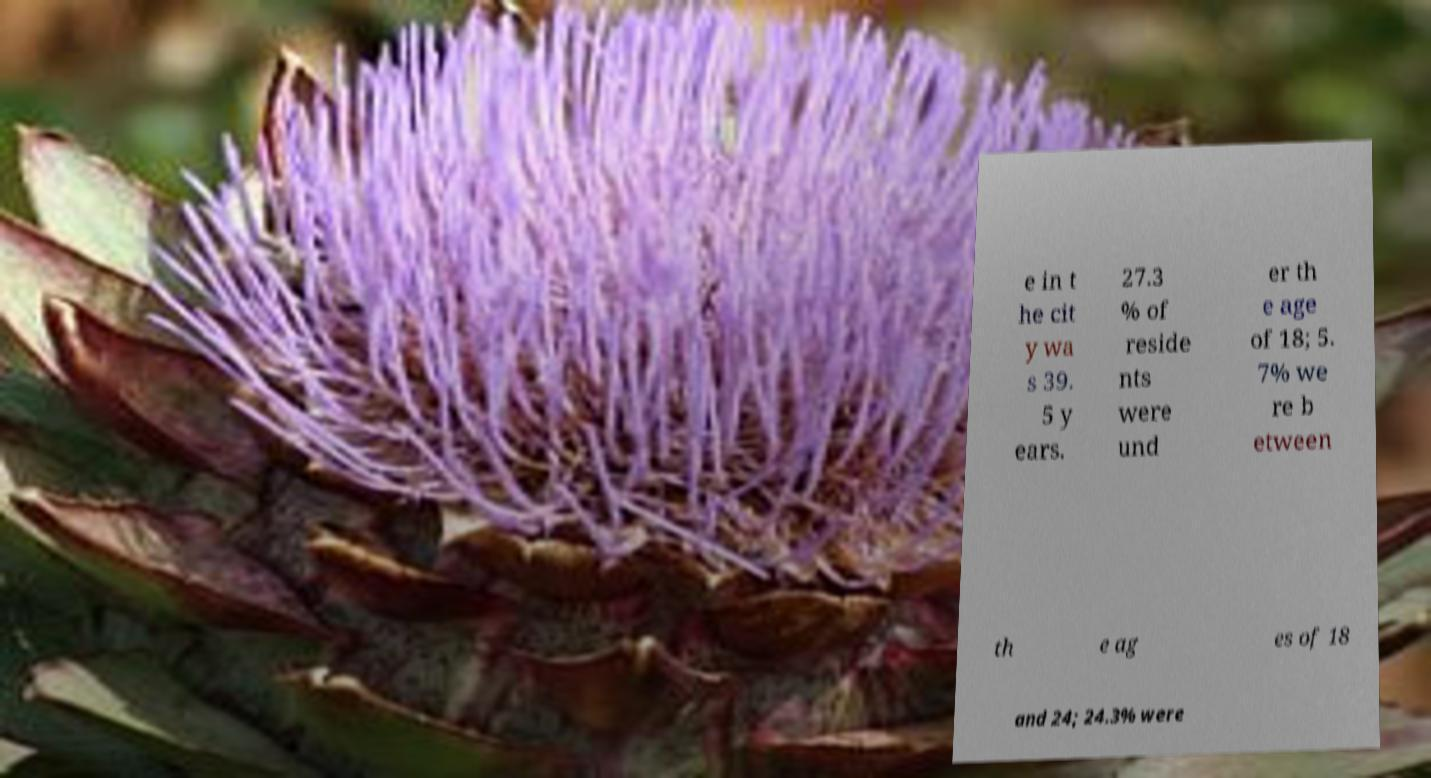Can you accurately transcribe the text from the provided image for me? e in t he cit y wa s 39. 5 y ears. 27.3 % of reside nts were und er th e age of 18; 5. 7% we re b etween th e ag es of 18 and 24; 24.3% were 